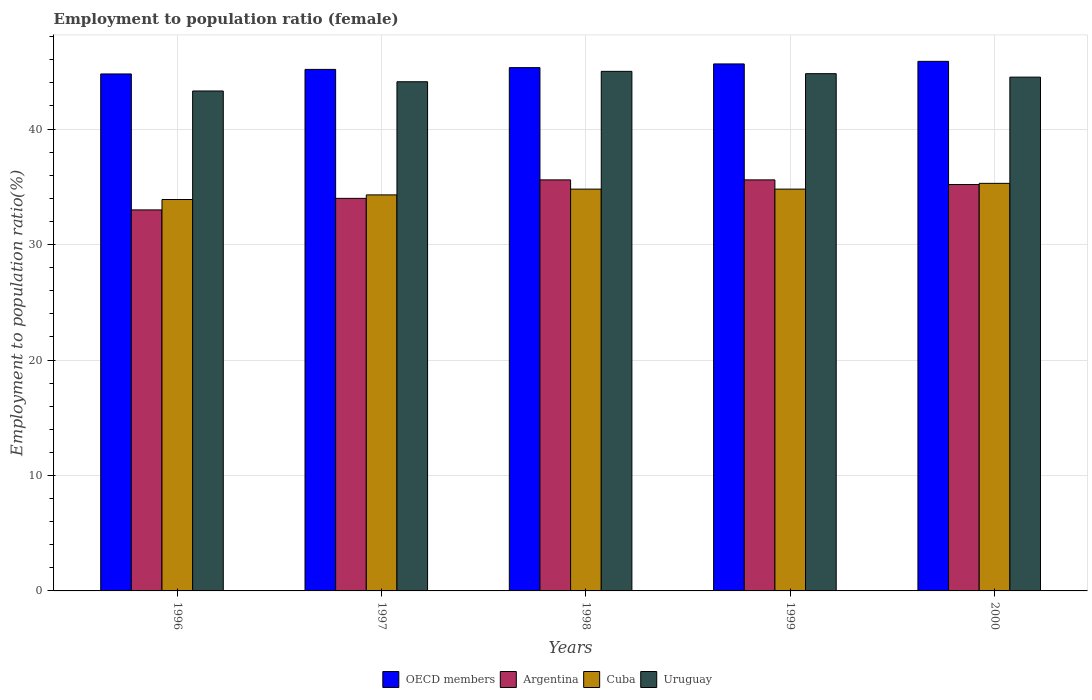How many groups of bars are there?
Your answer should be very brief. 5. Are the number of bars per tick equal to the number of legend labels?
Offer a very short reply. Yes. Are the number of bars on each tick of the X-axis equal?
Give a very brief answer. Yes. How many bars are there on the 1st tick from the left?
Ensure brevity in your answer.  4. How many bars are there on the 5th tick from the right?
Your answer should be very brief. 4. In how many cases, is the number of bars for a given year not equal to the number of legend labels?
Make the answer very short. 0. What is the employment to population ratio in Cuba in 1998?
Keep it short and to the point. 34.8. Across all years, what is the maximum employment to population ratio in OECD members?
Ensure brevity in your answer.  45.87. Across all years, what is the minimum employment to population ratio in OECD members?
Provide a succinct answer. 44.78. In which year was the employment to population ratio in Argentina minimum?
Your answer should be very brief. 1996. What is the total employment to population ratio in Uruguay in the graph?
Your response must be concise. 221.7. What is the difference between the employment to population ratio in Uruguay in 1999 and that in 2000?
Provide a succinct answer. 0.3. What is the difference between the employment to population ratio in Cuba in 1996 and the employment to population ratio in OECD members in 1999?
Offer a terse response. -11.74. What is the average employment to population ratio in Uruguay per year?
Make the answer very short. 44.34. In the year 1999, what is the difference between the employment to population ratio in OECD members and employment to population ratio in Cuba?
Provide a succinct answer. 10.84. In how many years, is the employment to population ratio in Cuba greater than 10 %?
Keep it short and to the point. 5. What is the ratio of the employment to population ratio in Argentina in 1997 to that in 1998?
Your answer should be compact. 0.96. What is the difference between the highest and the second highest employment to population ratio in Argentina?
Offer a very short reply. 0. What is the difference between the highest and the lowest employment to population ratio in OECD members?
Offer a terse response. 1.09. Is it the case that in every year, the sum of the employment to population ratio in Cuba and employment to population ratio in Uruguay is greater than the sum of employment to population ratio in Argentina and employment to population ratio in OECD members?
Provide a short and direct response. Yes. What does the 4th bar from the left in 2000 represents?
Offer a very short reply. Uruguay. What does the 1st bar from the right in 2000 represents?
Give a very brief answer. Uruguay. How many bars are there?
Give a very brief answer. 20. How many years are there in the graph?
Ensure brevity in your answer.  5. What is the difference between two consecutive major ticks on the Y-axis?
Your answer should be compact. 10. Are the values on the major ticks of Y-axis written in scientific E-notation?
Offer a very short reply. No. Does the graph contain any zero values?
Your answer should be compact. No. How many legend labels are there?
Keep it short and to the point. 4. What is the title of the graph?
Ensure brevity in your answer.  Employment to population ratio (female). What is the Employment to population ratio(%) of OECD members in 1996?
Offer a terse response. 44.78. What is the Employment to population ratio(%) in Cuba in 1996?
Offer a terse response. 33.9. What is the Employment to population ratio(%) of Uruguay in 1996?
Your answer should be compact. 43.3. What is the Employment to population ratio(%) in OECD members in 1997?
Offer a terse response. 45.17. What is the Employment to population ratio(%) in Cuba in 1997?
Offer a very short reply. 34.3. What is the Employment to population ratio(%) of Uruguay in 1997?
Give a very brief answer. 44.1. What is the Employment to population ratio(%) of OECD members in 1998?
Your answer should be very brief. 45.32. What is the Employment to population ratio(%) of Argentina in 1998?
Your response must be concise. 35.6. What is the Employment to population ratio(%) of Cuba in 1998?
Provide a succinct answer. 34.8. What is the Employment to population ratio(%) of Uruguay in 1998?
Provide a short and direct response. 45. What is the Employment to population ratio(%) in OECD members in 1999?
Make the answer very short. 45.64. What is the Employment to population ratio(%) in Argentina in 1999?
Offer a very short reply. 35.6. What is the Employment to population ratio(%) in Cuba in 1999?
Your answer should be compact. 34.8. What is the Employment to population ratio(%) in Uruguay in 1999?
Offer a very short reply. 44.8. What is the Employment to population ratio(%) of OECD members in 2000?
Provide a succinct answer. 45.87. What is the Employment to population ratio(%) in Argentina in 2000?
Your answer should be compact. 35.2. What is the Employment to population ratio(%) of Cuba in 2000?
Your response must be concise. 35.3. What is the Employment to population ratio(%) of Uruguay in 2000?
Make the answer very short. 44.5. Across all years, what is the maximum Employment to population ratio(%) in OECD members?
Offer a terse response. 45.87. Across all years, what is the maximum Employment to population ratio(%) in Argentina?
Your response must be concise. 35.6. Across all years, what is the maximum Employment to population ratio(%) in Cuba?
Your answer should be compact. 35.3. Across all years, what is the maximum Employment to population ratio(%) in Uruguay?
Ensure brevity in your answer.  45. Across all years, what is the minimum Employment to population ratio(%) in OECD members?
Offer a terse response. 44.78. Across all years, what is the minimum Employment to population ratio(%) in Argentina?
Keep it short and to the point. 33. Across all years, what is the minimum Employment to population ratio(%) of Cuba?
Your answer should be very brief. 33.9. Across all years, what is the minimum Employment to population ratio(%) in Uruguay?
Offer a terse response. 43.3. What is the total Employment to population ratio(%) of OECD members in the graph?
Your response must be concise. 226.78. What is the total Employment to population ratio(%) in Argentina in the graph?
Offer a terse response. 173.4. What is the total Employment to population ratio(%) in Cuba in the graph?
Offer a terse response. 173.1. What is the total Employment to population ratio(%) in Uruguay in the graph?
Make the answer very short. 221.7. What is the difference between the Employment to population ratio(%) in OECD members in 1996 and that in 1997?
Ensure brevity in your answer.  -0.39. What is the difference between the Employment to population ratio(%) of Argentina in 1996 and that in 1997?
Your answer should be compact. -1. What is the difference between the Employment to population ratio(%) of Cuba in 1996 and that in 1997?
Provide a short and direct response. -0.4. What is the difference between the Employment to population ratio(%) in Uruguay in 1996 and that in 1997?
Your response must be concise. -0.8. What is the difference between the Employment to population ratio(%) in OECD members in 1996 and that in 1998?
Provide a short and direct response. -0.55. What is the difference between the Employment to population ratio(%) in Argentina in 1996 and that in 1998?
Offer a terse response. -2.6. What is the difference between the Employment to population ratio(%) in Cuba in 1996 and that in 1998?
Give a very brief answer. -0.9. What is the difference between the Employment to population ratio(%) of OECD members in 1996 and that in 1999?
Offer a very short reply. -0.87. What is the difference between the Employment to population ratio(%) of Cuba in 1996 and that in 1999?
Give a very brief answer. -0.9. What is the difference between the Employment to population ratio(%) of OECD members in 1996 and that in 2000?
Offer a terse response. -1.09. What is the difference between the Employment to population ratio(%) in Uruguay in 1996 and that in 2000?
Offer a very short reply. -1.2. What is the difference between the Employment to population ratio(%) of OECD members in 1997 and that in 1998?
Keep it short and to the point. -0.15. What is the difference between the Employment to population ratio(%) of Argentina in 1997 and that in 1998?
Give a very brief answer. -1.6. What is the difference between the Employment to population ratio(%) in OECD members in 1997 and that in 1999?
Provide a succinct answer. -0.47. What is the difference between the Employment to population ratio(%) of Uruguay in 1997 and that in 1999?
Offer a terse response. -0.7. What is the difference between the Employment to population ratio(%) in OECD members in 1997 and that in 2000?
Your response must be concise. -0.7. What is the difference between the Employment to population ratio(%) in Argentina in 1997 and that in 2000?
Keep it short and to the point. -1.2. What is the difference between the Employment to population ratio(%) of Uruguay in 1997 and that in 2000?
Ensure brevity in your answer.  -0.4. What is the difference between the Employment to population ratio(%) in OECD members in 1998 and that in 1999?
Offer a terse response. -0.32. What is the difference between the Employment to population ratio(%) in Uruguay in 1998 and that in 1999?
Ensure brevity in your answer.  0.2. What is the difference between the Employment to population ratio(%) of OECD members in 1998 and that in 2000?
Your answer should be compact. -0.54. What is the difference between the Employment to population ratio(%) of Uruguay in 1998 and that in 2000?
Offer a terse response. 0.5. What is the difference between the Employment to population ratio(%) in OECD members in 1999 and that in 2000?
Ensure brevity in your answer.  -0.22. What is the difference between the Employment to population ratio(%) of Cuba in 1999 and that in 2000?
Your response must be concise. -0.5. What is the difference between the Employment to population ratio(%) of Uruguay in 1999 and that in 2000?
Offer a terse response. 0.3. What is the difference between the Employment to population ratio(%) in OECD members in 1996 and the Employment to population ratio(%) in Argentina in 1997?
Give a very brief answer. 10.78. What is the difference between the Employment to population ratio(%) of OECD members in 1996 and the Employment to population ratio(%) of Cuba in 1997?
Keep it short and to the point. 10.48. What is the difference between the Employment to population ratio(%) in OECD members in 1996 and the Employment to population ratio(%) in Uruguay in 1997?
Provide a succinct answer. 0.68. What is the difference between the Employment to population ratio(%) of Argentina in 1996 and the Employment to population ratio(%) of Uruguay in 1997?
Your answer should be very brief. -11.1. What is the difference between the Employment to population ratio(%) of OECD members in 1996 and the Employment to population ratio(%) of Argentina in 1998?
Provide a succinct answer. 9.18. What is the difference between the Employment to population ratio(%) in OECD members in 1996 and the Employment to population ratio(%) in Cuba in 1998?
Ensure brevity in your answer.  9.98. What is the difference between the Employment to population ratio(%) in OECD members in 1996 and the Employment to population ratio(%) in Uruguay in 1998?
Provide a short and direct response. -0.22. What is the difference between the Employment to population ratio(%) in Argentina in 1996 and the Employment to population ratio(%) in Cuba in 1998?
Make the answer very short. -1.8. What is the difference between the Employment to population ratio(%) in Argentina in 1996 and the Employment to population ratio(%) in Uruguay in 1998?
Offer a very short reply. -12. What is the difference between the Employment to population ratio(%) in Cuba in 1996 and the Employment to population ratio(%) in Uruguay in 1998?
Make the answer very short. -11.1. What is the difference between the Employment to population ratio(%) of OECD members in 1996 and the Employment to population ratio(%) of Argentina in 1999?
Your answer should be very brief. 9.18. What is the difference between the Employment to population ratio(%) of OECD members in 1996 and the Employment to population ratio(%) of Cuba in 1999?
Your answer should be very brief. 9.98. What is the difference between the Employment to population ratio(%) in OECD members in 1996 and the Employment to population ratio(%) in Uruguay in 1999?
Keep it short and to the point. -0.02. What is the difference between the Employment to population ratio(%) of Argentina in 1996 and the Employment to population ratio(%) of Cuba in 1999?
Provide a succinct answer. -1.8. What is the difference between the Employment to population ratio(%) of OECD members in 1996 and the Employment to population ratio(%) of Argentina in 2000?
Provide a short and direct response. 9.58. What is the difference between the Employment to population ratio(%) in OECD members in 1996 and the Employment to population ratio(%) in Cuba in 2000?
Offer a very short reply. 9.48. What is the difference between the Employment to population ratio(%) of OECD members in 1996 and the Employment to population ratio(%) of Uruguay in 2000?
Make the answer very short. 0.28. What is the difference between the Employment to population ratio(%) in Argentina in 1996 and the Employment to population ratio(%) in Uruguay in 2000?
Your answer should be compact. -11.5. What is the difference between the Employment to population ratio(%) of OECD members in 1997 and the Employment to population ratio(%) of Argentina in 1998?
Your response must be concise. 9.57. What is the difference between the Employment to population ratio(%) in OECD members in 1997 and the Employment to population ratio(%) in Cuba in 1998?
Give a very brief answer. 10.37. What is the difference between the Employment to population ratio(%) of OECD members in 1997 and the Employment to population ratio(%) of Uruguay in 1998?
Ensure brevity in your answer.  0.17. What is the difference between the Employment to population ratio(%) in Cuba in 1997 and the Employment to population ratio(%) in Uruguay in 1998?
Your response must be concise. -10.7. What is the difference between the Employment to population ratio(%) of OECD members in 1997 and the Employment to population ratio(%) of Argentina in 1999?
Give a very brief answer. 9.57. What is the difference between the Employment to population ratio(%) of OECD members in 1997 and the Employment to population ratio(%) of Cuba in 1999?
Offer a very short reply. 10.37. What is the difference between the Employment to population ratio(%) of OECD members in 1997 and the Employment to population ratio(%) of Uruguay in 1999?
Provide a short and direct response. 0.37. What is the difference between the Employment to population ratio(%) in Cuba in 1997 and the Employment to population ratio(%) in Uruguay in 1999?
Keep it short and to the point. -10.5. What is the difference between the Employment to population ratio(%) in OECD members in 1997 and the Employment to population ratio(%) in Argentina in 2000?
Give a very brief answer. 9.97. What is the difference between the Employment to population ratio(%) of OECD members in 1997 and the Employment to population ratio(%) of Cuba in 2000?
Your answer should be compact. 9.87. What is the difference between the Employment to population ratio(%) of OECD members in 1997 and the Employment to population ratio(%) of Uruguay in 2000?
Provide a short and direct response. 0.67. What is the difference between the Employment to population ratio(%) of Argentina in 1997 and the Employment to population ratio(%) of Cuba in 2000?
Ensure brevity in your answer.  -1.3. What is the difference between the Employment to population ratio(%) in Argentina in 1997 and the Employment to population ratio(%) in Uruguay in 2000?
Your answer should be compact. -10.5. What is the difference between the Employment to population ratio(%) of Cuba in 1997 and the Employment to population ratio(%) of Uruguay in 2000?
Keep it short and to the point. -10.2. What is the difference between the Employment to population ratio(%) of OECD members in 1998 and the Employment to population ratio(%) of Argentina in 1999?
Give a very brief answer. 9.72. What is the difference between the Employment to population ratio(%) in OECD members in 1998 and the Employment to population ratio(%) in Cuba in 1999?
Keep it short and to the point. 10.52. What is the difference between the Employment to population ratio(%) of OECD members in 1998 and the Employment to population ratio(%) of Uruguay in 1999?
Make the answer very short. 0.52. What is the difference between the Employment to population ratio(%) in Argentina in 1998 and the Employment to population ratio(%) in Uruguay in 1999?
Provide a succinct answer. -9.2. What is the difference between the Employment to population ratio(%) of Cuba in 1998 and the Employment to population ratio(%) of Uruguay in 1999?
Give a very brief answer. -10. What is the difference between the Employment to population ratio(%) in OECD members in 1998 and the Employment to population ratio(%) in Argentina in 2000?
Your response must be concise. 10.12. What is the difference between the Employment to population ratio(%) of OECD members in 1998 and the Employment to population ratio(%) of Cuba in 2000?
Ensure brevity in your answer.  10.02. What is the difference between the Employment to population ratio(%) in OECD members in 1998 and the Employment to population ratio(%) in Uruguay in 2000?
Your answer should be very brief. 0.82. What is the difference between the Employment to population ratio(%) of Argentina in 1998 and the Employment to population ratio(%) of Uruguay in 2000?
Your response must be concise. -8.9. What is the difference between the Employment to population ratio(%) in Cuba in 1998 and the Employment to population ratio(%) in Uruguay in 2000?
Your response must be concise. -9.7. What is the difference between the Employment to population ratio(%) of OECD members in 1999 and the Employment to population ratio(%) of Argentina in 2000?
Provide a succinct answer. 10.44. What is the difference between the Employment to population ratio(%) in OECD members in 1999 and the Employment to population ratio(%) in Cuba in 2000?
Your response must be concise. 10.34. What is the difference between the Employment to population ratio(%) of OECD members in 1999 and the Employment to population ratio(%) of Uruguay in 2000?
Make the answer very short. 1.14. What is the difference between the Employment to population ratio(%) in Cuba in 1999 and the Employment to population ratio(%) in Uruguay in 2000?
Provide a short and direct response. -9.7. What is the average Employment to population ratio(%) of OECD members per year?
Your answer should be very brief. 45.35. What is the average Employment to population ratio(%) in Argentina per year?
Keep it short and to the point. 34.68. What is the average Employment to population ratio(%) in Cuba per year?
Provide a short and direct response. 34.62. What is the average Employment to population ratio(%) in Uruguay per year?
Provide a succinct answer. 44.34. In the year 1996, what is the difference between the Employment to population ratio(%) in OECD members and Employment to population ratio(%) in Argentina?
Ensure brevity in your answer.  11.78. In the year 1996, what is the difference between the Employment to population ratio(%) of OECD members and Employment to population ratio(%) of Cuba?
Your answer should be compact. 10.88. In the year 1996, what is the difference between the Employment to population ratio(%) in OECD members and Employment to population ratio(%) in Uruguay?
Keep it short and to the point. 1.48. In the year 1996, what is the difference between the Employment to population ratio(%) in Cuba and Employment to population ratio(%) in Uruguay?
Your answer should be very brief. -9.4. In the year 1997, what is the difference between the Employment to population ratio(%) in OECD members and Employment to population ratio(%) in Argentina?
Offer a terse response. 11.17. In the year 1997, what is the difference between the Employment to population ratio(%) of OECD members and Employment to population ratio(%) of Cuba?
Make the answer very short. 10.87. In the year 1997, what is the difference between the Employment to population ratio(%) of OECD members and Employment to population ratio(%) of Uruguay?
Make the answer very short. 1.07. In the year 1997, what is the difference between the Employment to population ratio(%) of Argentina and Employment to population ratio(%) of Cuba?
Make the answer very short. -0.3. In the year 1997, what is the difference between the Employment to population ratio(%) in Argentina and Employment to population ratio(%) in Uruguay?
Your answer should be compact. -10.1. In the year 1998, what is the difference between the Employment to population ratio(%) of OECD members and Employment to population ratio(%) of Argentina?
Ensure brevity in your answer.  9.72. In the year 1998, what is the difference between the Employment to population ratio(%) of OECD members and Employment to population ratio(%) of Cuba?
Ensure brevity in your answer.  10.52. In the year 1998, what is the difference between the Employment to population ratio(%) of OECD members and Employment to population ratio(%) of Uruguay?
Keep it short and to the point. 0.32. In the year 1998, what is the difference between the Employment to population ratio(%) of Argentina and Employment to population ratio(%) of Uruguay?
Offer a very short reply. -9.4. In the year 1999, what is the difference between the Employment to population ratio(%) in OECD members and Employment to population ratio(%) in Argentina?
Provide a succinct answer. 10.04. In the year 1999, what is the difference between the Employment to population ratio(%) in OECD members and Employment to population ratio(%) in Cuba?
Make the answer very short. 10.84. In the year 1999, what is the difference between the Employment to population ratio(%) of OECD members and Employment to population ratio(%) of Uruguay?
Ensure brevity in your answer.  0.84. In the year 1999, what is the difference between the Employment to population ratio(%) of Argentina and Employment to population ratio(%) of Uruguay?
Your response must be concise. -9.2. In the year 2000, what is the difference between the Employment to population ratio(%) of OECD members and Employment to population ratio(%) of Argentina?
Offer a terse response. 10.67. In the year 2000, what is the difference between the Employment to population ratio(%) of OECD members and Employment to population ratio(%) of Cuba?
Give a very brief answer. 10.57. In the year 2000, what is the difference between the Employment to population ratio(%) of OECD members and Employment to population ratio(%) of Uruguay?
Provide a short and direct response. 1.37. What is the ratio of the Employment to population ratio(%) in OECD members in 1996 to that in 1997?
Give a very brief answer. 0.99. What is the ratio of the Employment to population ratio(%) in Argentina in 1996 to that in 1997?
Your response must be concise. 0.97. What is the ratio of the Employment to population ratio(%) of Cuba in 1996 to that in 1997?
Your response must be concise. 0.99. What is the ratio of the Employment to population ratio(%) in Uruguay in 1996 to that in 1997?
Give a very brief answer. 0.98. What is the ratio of the Employment to population ratio(%) of OECD members in 1996 to that in 1998?
Your response must be concise. 0.99. What is the ratio of the Employment to population ratio(%) of Argentina in 1996 to that in 1998?
Keep it short and to the point. 0.93. What is the ratio of the Employment to population ratio(%) in Cuba in 1996 to that in 1998?
Provide a short and direct response. 0.97. What is the ratio of the Employment to population ratio(%) of Uruguay in 1996 to that in 1998?
Make the answer very short. 0.96. What is the ratio of the Employment to population ratio(%) of Argentina in 1996 to that in 1999?
Keep it short and to the point. 0.93. What is the ratio of the Employment to population ratio(%) of Cuba in 1996 to that in 1999?
Your answer should be compact. 0.97. What is the ratio of the Employment to population ratio(%) of Uruguay in 1996 to that in 1999?
Give a very brief answer. 0.97. What is the ratio of the Employment to population ratio(%) of OECD members in 1996 to that in 2000?
Keep it short and to the point. 0.98. What is the ratio of the Employment to population ratio(%) of Argentina in 1996 to that in 2000?
Make the answer very short. 0.94. What is the ratio of the Employment to population ratio(%) of Cuba in 1996 to that in 2000?
Your answer should be very brief. 0.96. What is the ratio of the Employment to population ratio(%) of OECD members in 1997 to that in 1998?
Offer a terse response. 1. What is the ratio of the Employment to population ratio(%) in Argentina in 1997 to that in 1998?
Offer a very short reply. 0.96. What is the ratio of the Employment to population ratio(%) of Cuba in 1997 to that in 1998?
Your response must be concise. 0.99. What is the ratio of the Employment to population ratio(%) of OECD members in 1997 to that in 1999?
Offer a terse response. 0.99. What is the ratio of the Employment to population ratio(%) in Argentina in 1997 to that in 1999?
Give a very brief answer. 0.96. What is the ratio of the Employment to population ratio(%) in Cuba in 1997 to that in 1999?
Provide a short and direct response. 0.99. What is the ratio of the Employment to population ratio(%) in Uruguay in 1997 to that in 1999?
Your response must be concise. 0.98. What is the ratio of the Employment to population ratio(%) in Argentina in 1997 to that in 2000?
Your answer should be compact. 0.97. What is the ratio of the Employment to population ratio(%) of Cuba in 1997 to that in 2000?
Provide a short and direct response. 0.97. What is the ratio of the Employment to population ratio(%) of Argentina in 1998 to that in 1999?
Your response must be concise. 1. What is the ratio of the Employment to population ratio(%) of Uruguay in 1998 to that in 1999?
Offer a terse response. 1. What is the ratio of the Employment to population ratio(%) in Argentina in 1998 to that in 2000?
Give a very brief answer. 1.01. What is the ratio of the Employment to population ratio(%) of Cuba in 1998 to that in 2000?
Your answer should be compact. 0.99. What is the ratio of the Employment to population ratio(%) in Uruguay in 1998 to that in 2000?
Offer a very short reply. 1.01. What is the ratio of the Employment to population ratio(%) in Argentina in 1999 to that in 2000?
Your answer should be compact. 1.01. What is the ratio of the Employment to population ratio(%) in Cuba in 1999 to that in 2000?
Give a very brief answer. 0.99. What is the difference between the highest and the second highest Employment to population ratio(%) of OECD members?
Provide a succinct answer. 0.22. What is the difference between the highest and the second highest Employment to population ratio(%) of Argentina?
Your answer should be very brief. 0. What is the difference between the highest and the lowest Employment to population ratio(%) of OECD members?
Provide a succinct answer. 1.09. What is the difference between the highest and the lowest Employment to population ratio(%) of Argentina?
Ensure brevity in your answer.  2.6. 